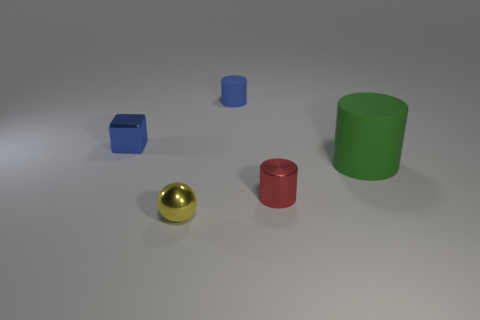Add 3 green matte things. How many objects exist? 8 Subtract all cylinders. How many objects are left? 2 Add 1 tiny yellow metallic spheres. How many tiny yellow metallic spheres exist? 2 Subtract 0 purple blocks. How many objects are left? 5 Subtract all small brown blocks. Subtract all small red cylinders. How many objects are left? 4 Add 5 small metal objects. How many small metal objects are left? 8 